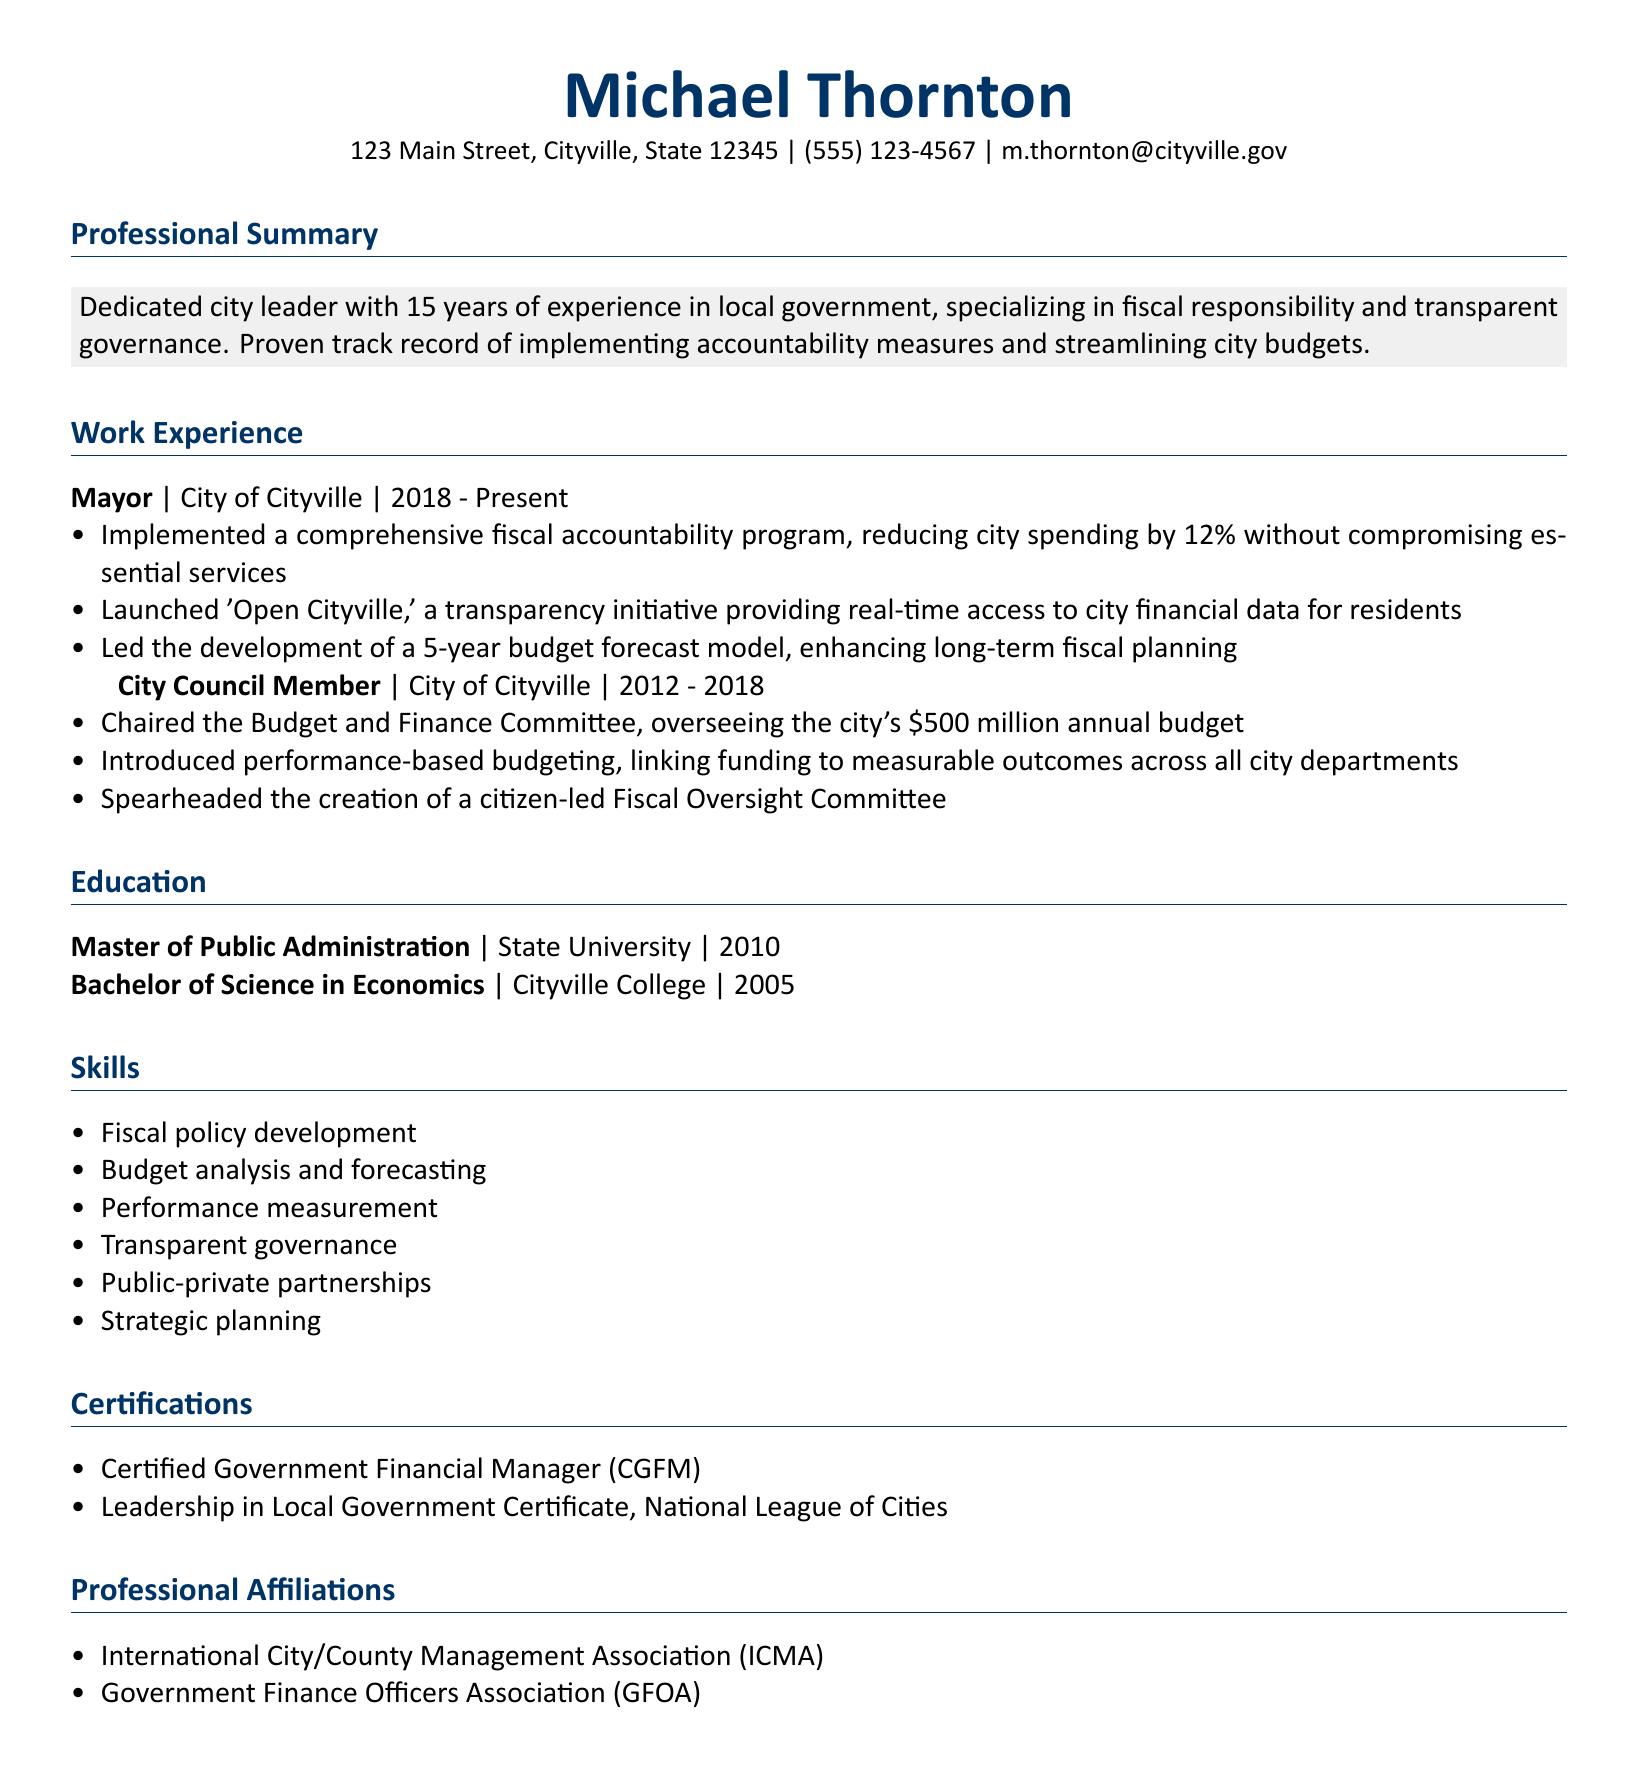what is Michael Thornton's current title? His current title is mentioned under work experience as Mayor.
Answer: Mayor how long has Michael Thornton worked in local government? The professional summary states that he has 15 years of experience in local government.
Answer: 15 years what percentage did the fiscal accountability program reduce city spending by? The achievements under the Mayor title mention a reduction of spending by 12%.
Answer: 12% which initiative did Michael Thornton launch to enhance transparency? The document highlights the launch of 'Open Cityville' as a transparency initiative.
Answer: Open Cityville what degree did Michael Thornton earn in 2010? The education section indicates he earned a Master of Public Administration in 2010.
Answer: Master of Public Administration how much was the annual budget that Michael oversaw as a City Council Member? The achievements state he oversaw a $500 million annual budget.
Answer: $500 million what is one skill listed in the CV related to fiscal management? The skills section includes fiscal policy development as one of his skills.
Answer: Fiscal policy development which certification is related to government financial management? The certifications list includes Certified Government Financial Manager (CGFM), which is relevant to financial management.
Answer: Certified Government Financial Manager (CGFM) 